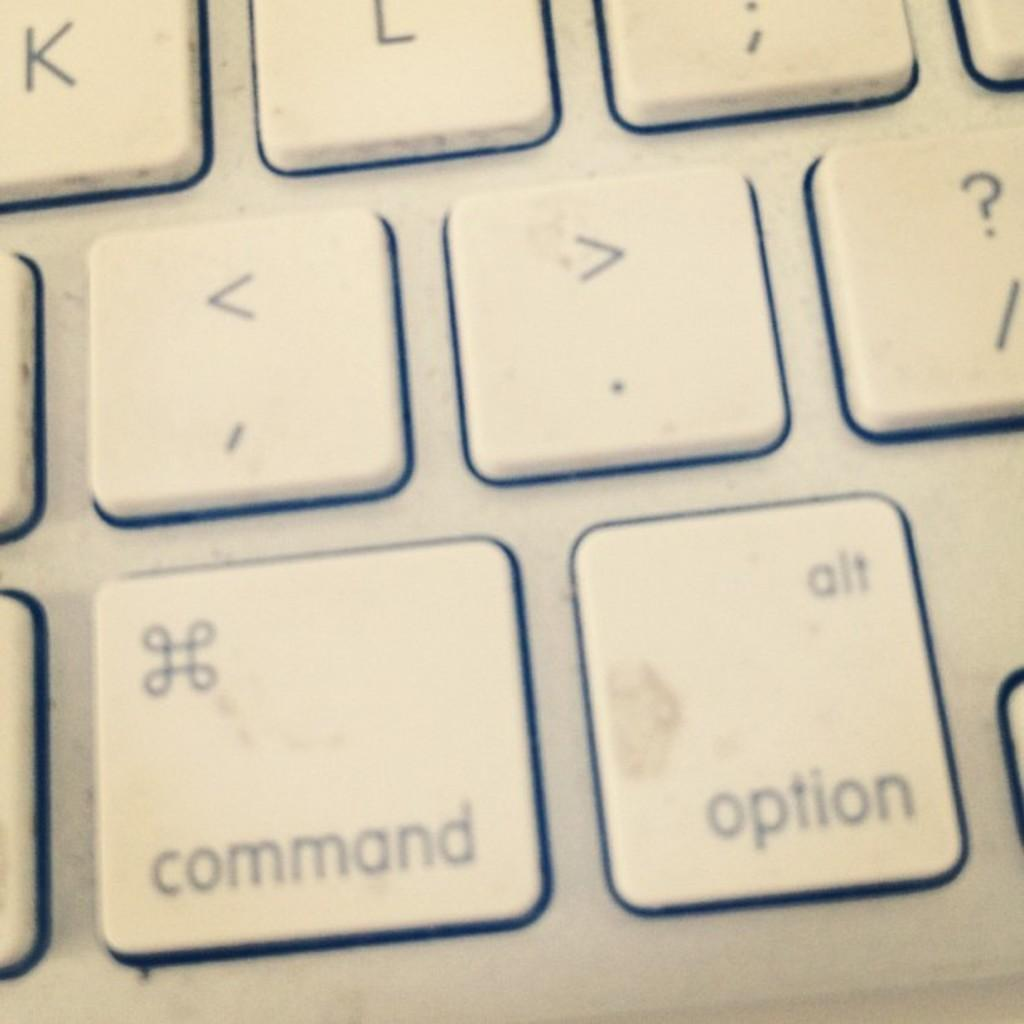<image>
Write a terse but informative summary of the picture. Close up on a mac keyboard showing the command, option and punctuation keys 